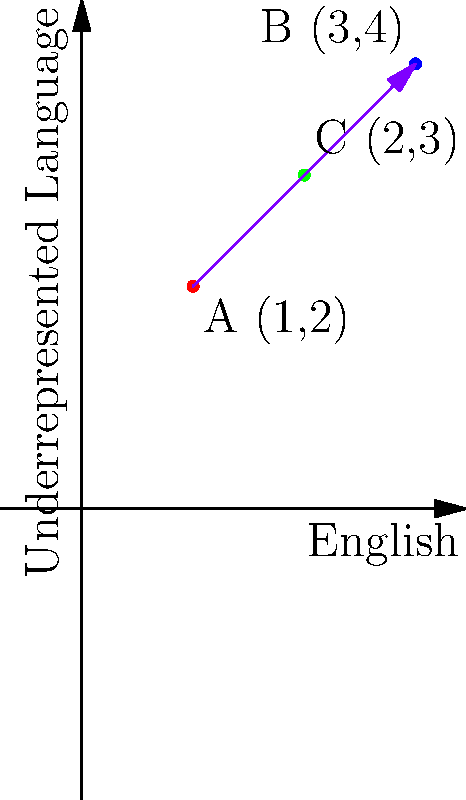A publishing company is translating sentences from English to an underrepresented language. In the coordinate system above, English words are represented on the x-axis, and their translations in the underrepresented language are on the y-axis. Point A represents the word "book", B represents "library", and C represents "read". If vector $\vec{AB}$ represents the transformation from "book" to "library", what are the coordinates of the point that would represent the translation of "write" in this system? To solve this problem, we need to follow these steps:

1. Identify the coordinates of points A and B:
   A (1,2) represents "book"
   B (3,4) represents "library"

2. Calculate the vector $\vec{AB}$:
   $\vec{AB} = B - A = (3,4) - (1,2) = (2,2)$

3. This vector represents the transformation from "book" to "library" in both languages. We can assume that a similar transformation would apply to "read" to get to "write".

4. Starting from point C (2,3) which represents "read", we add the vector $\vec{AB}$ to find the coordinates for "write":
   "write" = C + $\vec{AB} = (2,3) + (2,2) = (4,5)$

5. Therefore, the point representing "write" would be at coordinates (4,5) in this system.

This coordinate (4,5) means that "write" would be the 4th word in the English sequence and the 5th word in the underrepresented language sequence in this translation system.
Answer: (4,5) 